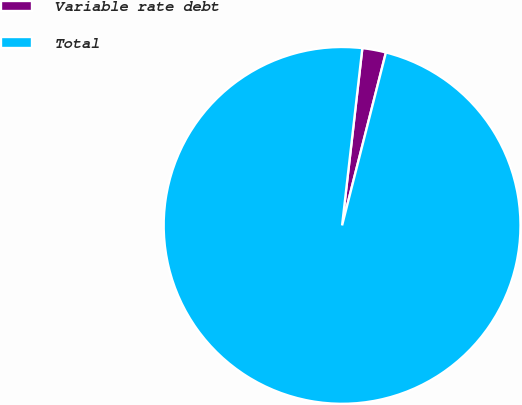<chart> <loc_0><loc_0><loc_500><loc_500><pie_chart><fcel>Variable rate debt<fcel>Total<nl><fcel>2.14%<fcel>97.86%<nl></chart> 